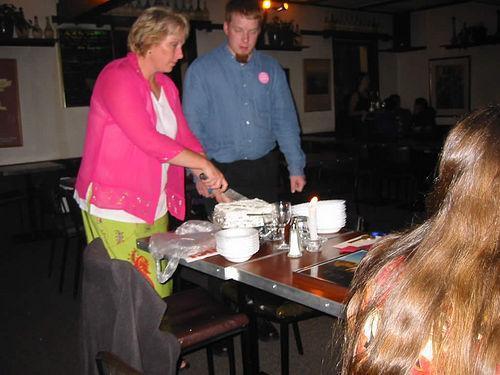How many people are at the table?
Give a very brief answer. 3. 